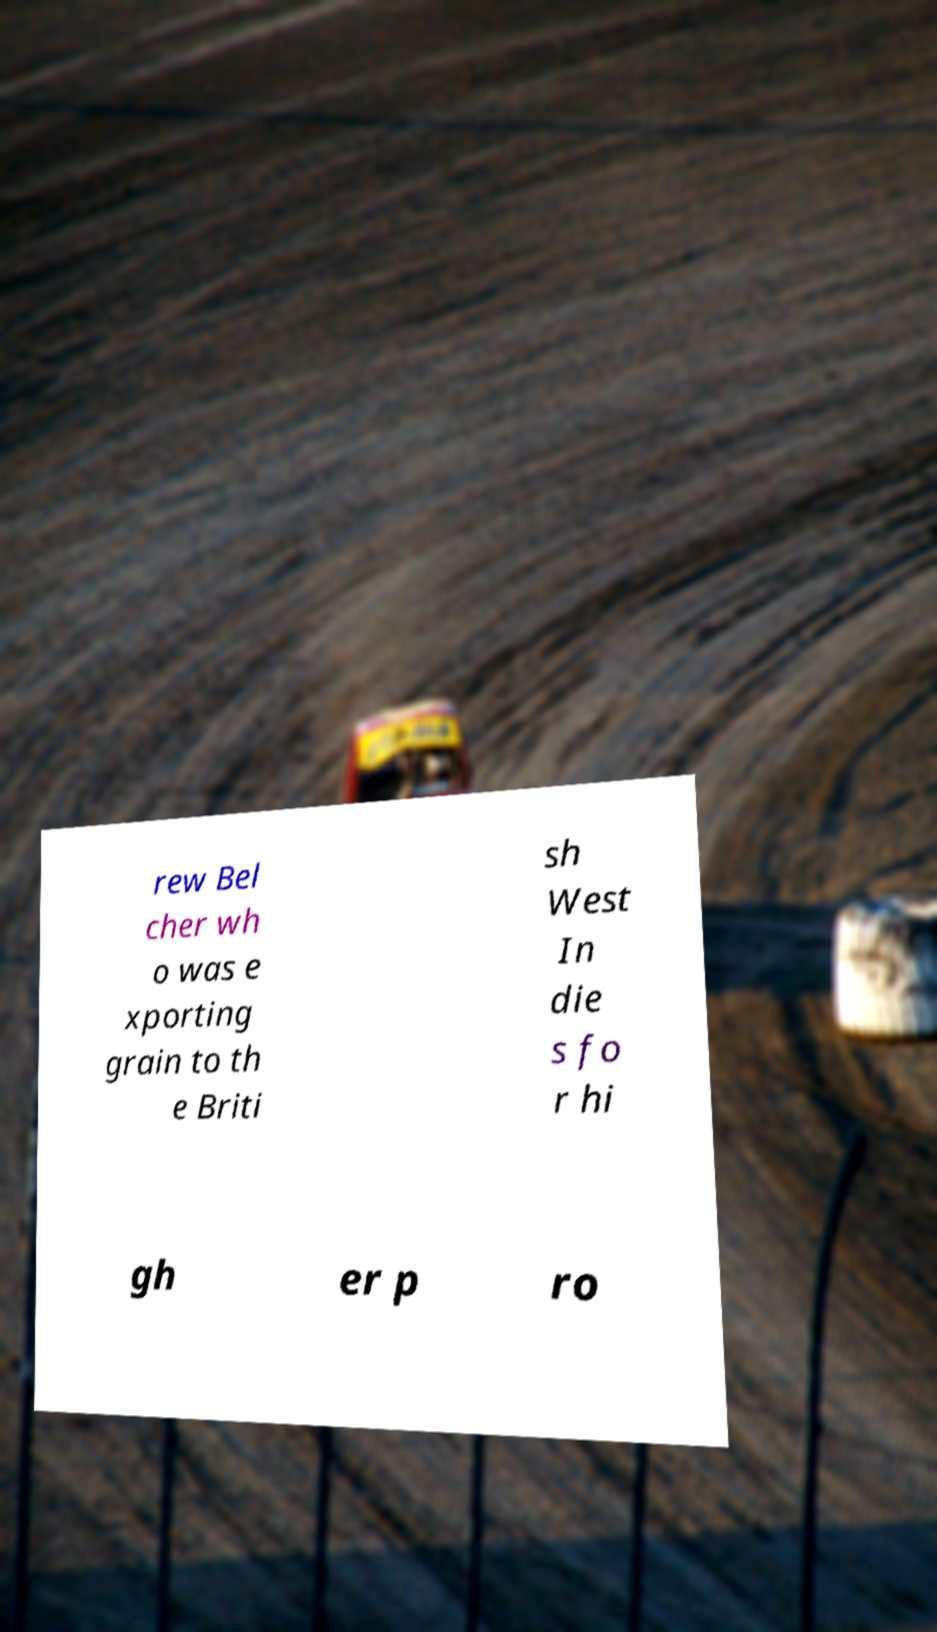Please read and relay the text visible in this image. What does it say? rew Bel cher wh o was e xporting grain to th e Briti sh West In die s fo r hi gh er p ro 